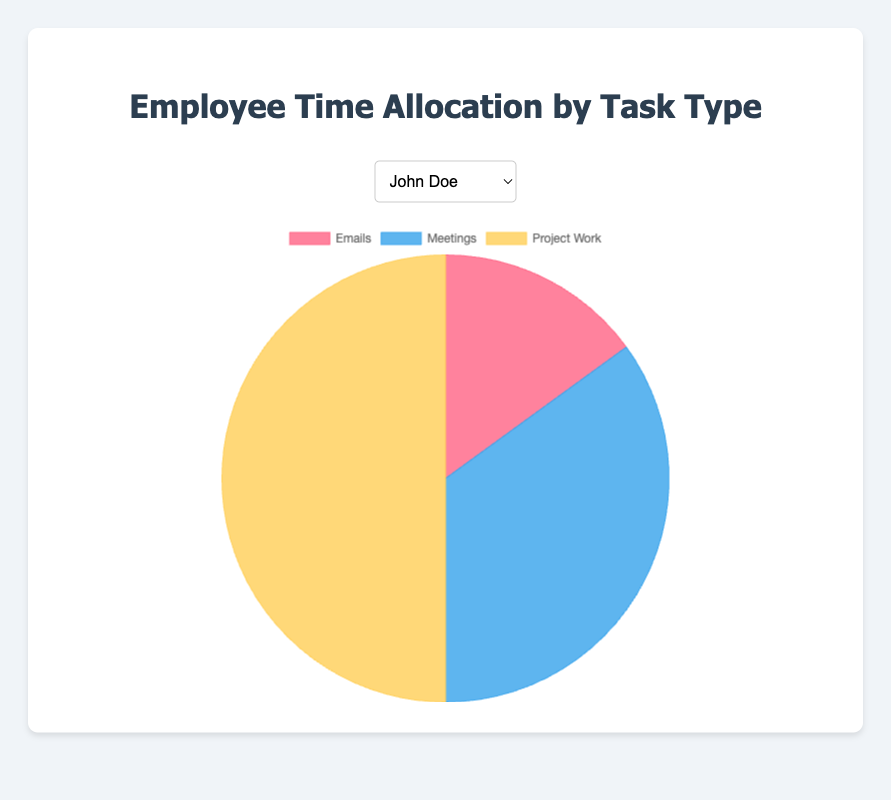What are the task types shown in the pie chart? The pie chart labels include 'Emails', 'Meetings', and 'Project Work'. You can see the labels represented in different colors within the chart.
Answer: Emails, Meetings, Project Work Which task type does John Doe spend the most time on? Referring to John Doe's pie chart, the largest segment is for 'Project Work'.
Answer: Project Work How does the proportion of time James Wilson spends on meetings compare to emails? In James Wilson's chart, the segment for 'Meetings' is significantly larger than 'Emails'.
Answer: Meetings > Emails What is the sum of the time Alice Smith spends on emails and project work? From Alice Smith's data, emails take 20%, and project work is 55%. Adding these together gives 75%.
Answer: 75% Whose chart shows an equal distribution between any two task types? Robert Brown's chart appears to have similar proportions for 'Emails' and 'Project Work' at 30% each.
Answer: Robert Brown Which task type does Laura White spend the least amount of time on? By observing Laura White's chart, the smallest segment is for 'Emails'.
Answer: Emails What is the average percentage of time allocated to meetings across all employees? Sum the meeting percentages: 35+25+40+30+50 = 180, then divide by 5 (number of employees): 180/5 = 36%.
Answer: 36% Which employee has the highest proportion of time spent on meetings? James Wilson’s chart has the largest 'Meetings' section at 50%, which is the highest among all employees.
Answer: James Wilson Compare the time allocation of John Doe and Laura White on project work. John Doe allocates 50% to 'Project Work' while Laura White allocates 45%.
Answer: John Doe > Laura White 